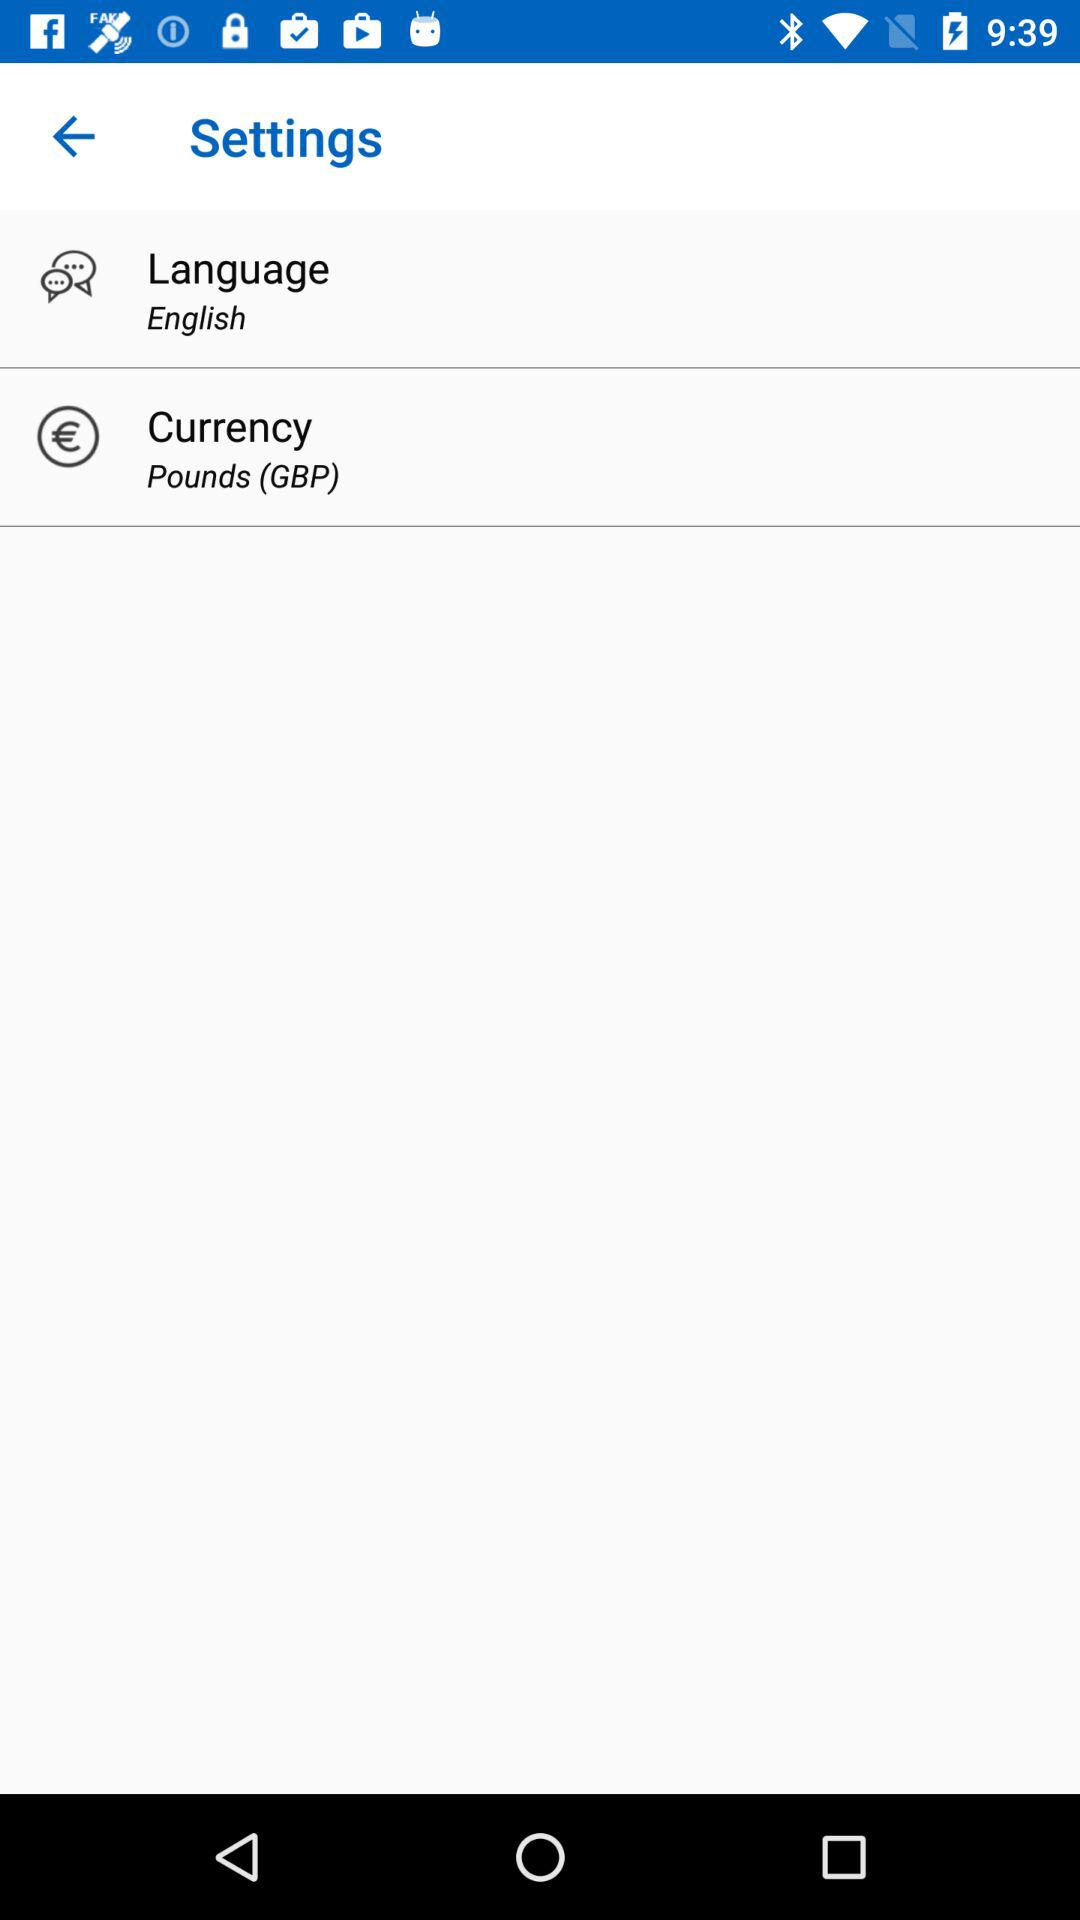Which currency is selected? The selected currency is pounds (GBP). 